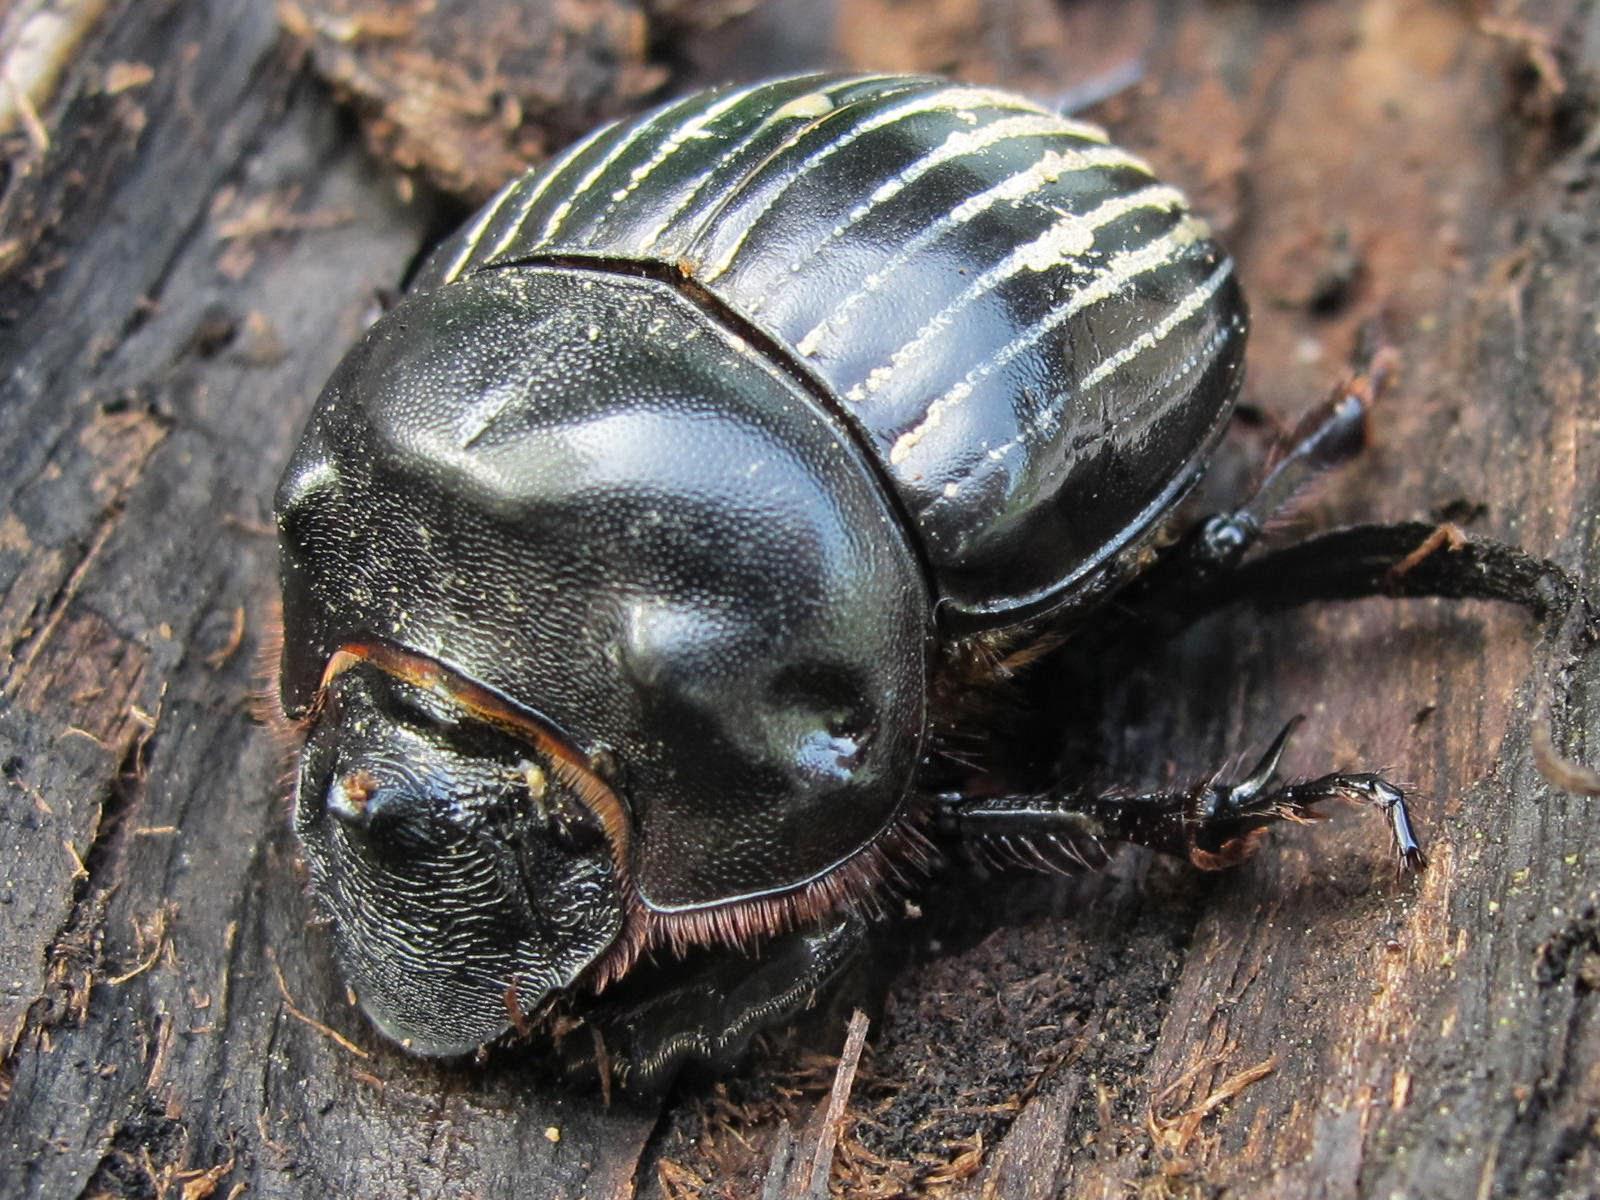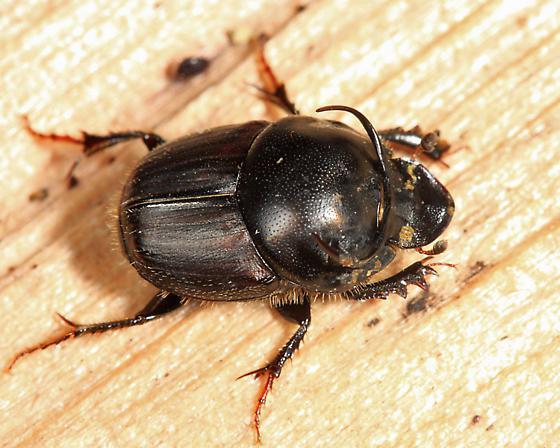The first image is the image on the left, the second image is the image on the right. For the images displayed, is the sentence "there is a ball of dung in the right pic" factually correct? Answer yes or no. No. The first image is the image on the left, the second image is the image on the right. Given the left and right images, does the statement "A beetle is pictured with a ball of dug." hold true? Answer yes or no. No. 